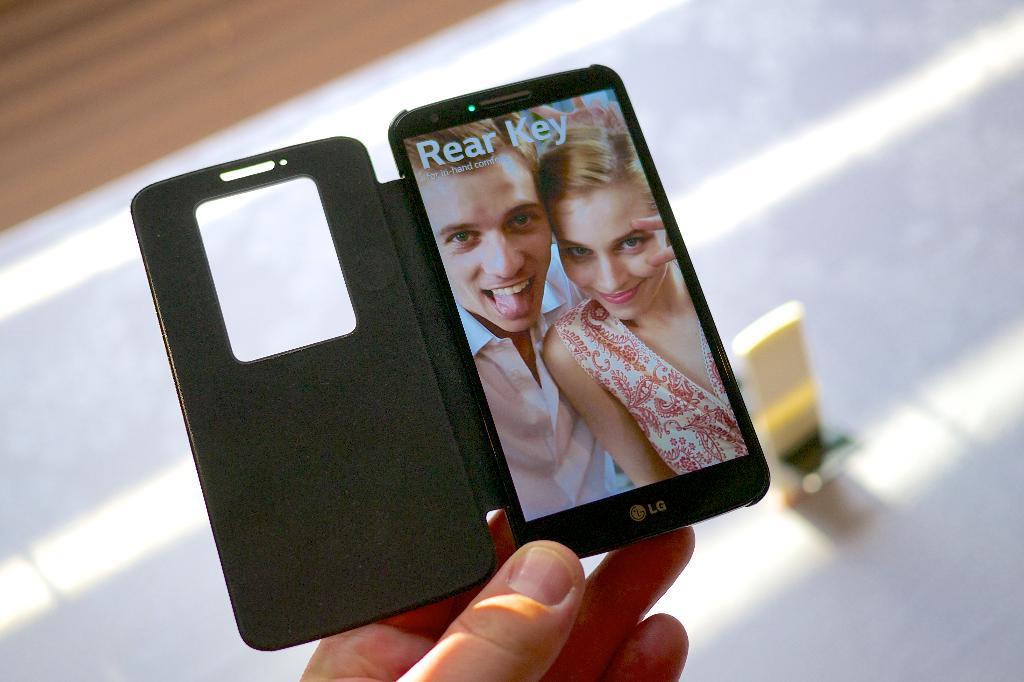What does the phone screen say?
Provide a succinct answer. Rear key. What brand is this phone?
Ensure brevity in your answer.  Lg. 